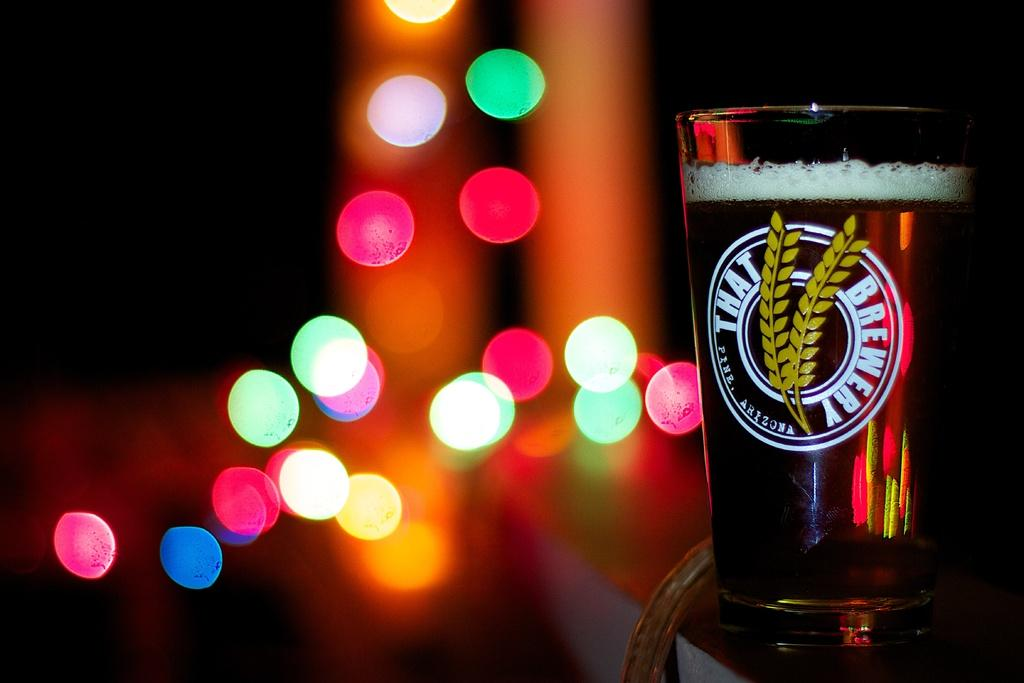<image>
Share a concise interpretation of the image provided. A full That Brewery glass has colorful light behind it. 